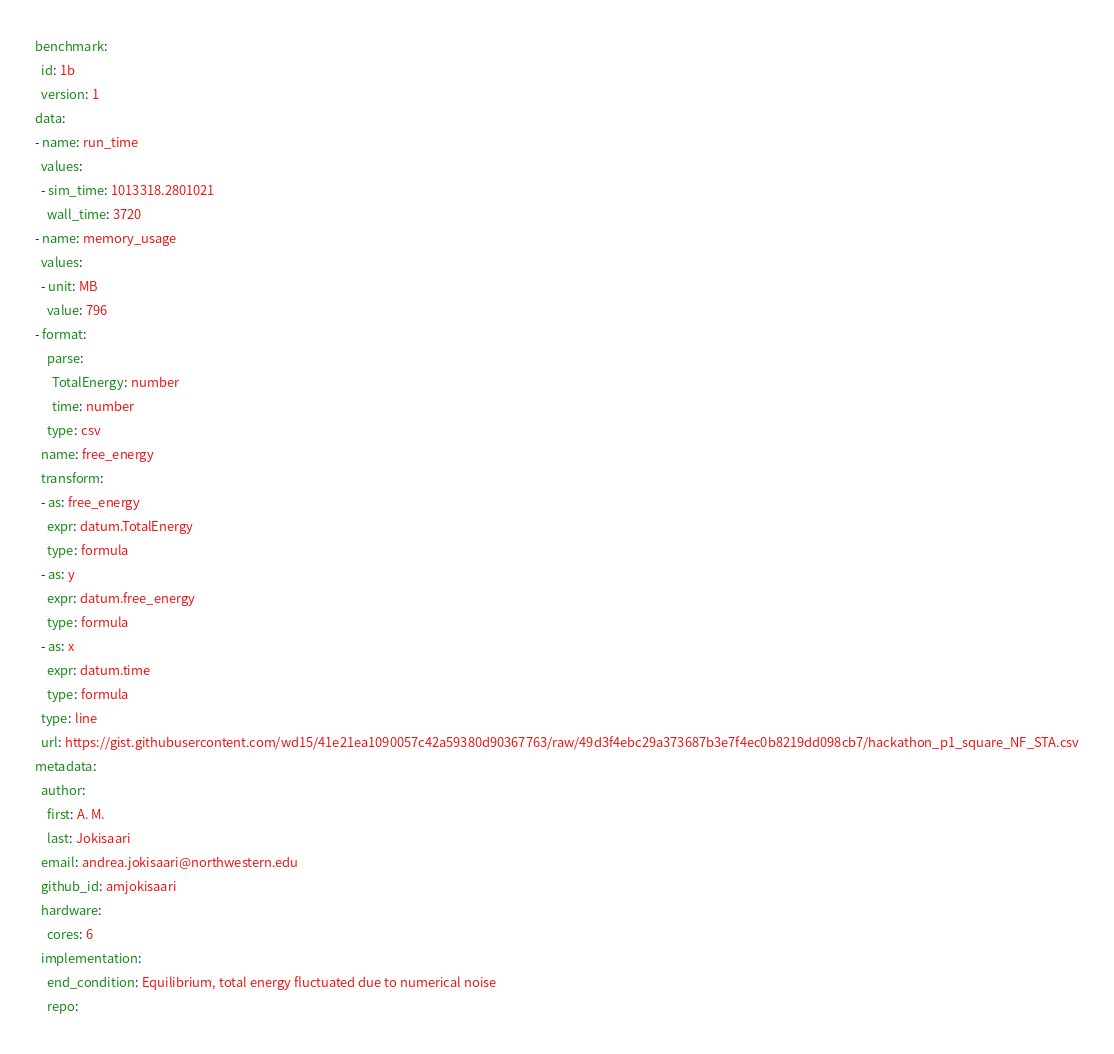Convert code to text. <code><loc_0><loc_0><loc_500><loc_500><_YAML_>benchmark:
  id: 1b
  version: 1
data:
- name: run_time
  values:
  - sim_time: 1013318.2801021
    wall_time: 3720
- name: memory_usage
  values:
  - unit: MB
    value: 796
- format:
    parse:
      TotalEnergy: number
      time: number
    type: csv
  name: free_energy
  transform:
  - as: free_energy
    expr: datum.TotalEnergy
    type: formula
  - as: y
    expr: datum.free_energy
    type: formula
  - as: x
    expr: datum.time
    type: formula
  type: line
  url: https://gist.githubusercontent.com/wd15/41e21ea1090057c42a59380d90367763/raw/49d3f4ebc29a373687b3e7f4ec0b8219dd098cb7/hackathon_p1_square_NF_STA.csv
metadata:
  author:
    first: A. M.
    last: Jokisaari
  email: andrea.jokisaari@northwestern.edu
  github_id: amjokisaari
  hardware:
    cores: 6
  implementation:
    end_condition: Equilibrium, total energy fluctuated due to numerical noise
    repo:</code> 